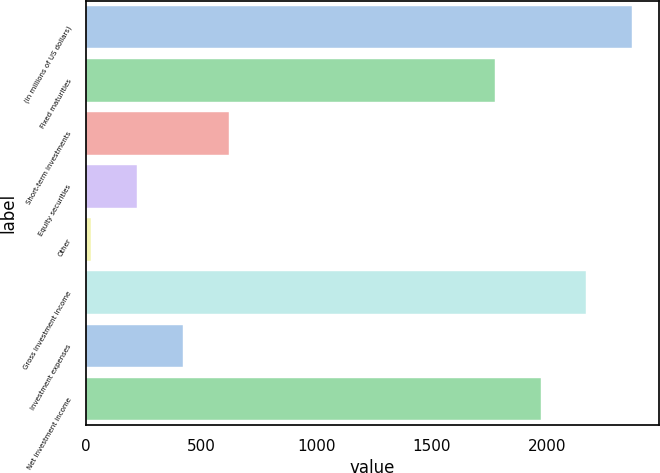<chart> <loc_0><loc_0><loc_500><loc_500><bar_chart><fcel>(in millions of US dollars)<fcel>Fixed maturities<fcel>Short-term investments<fcel>Equity securities<fcel>Other<fcel>Gross investment income<fcel>Investment expenses<fcel>Net investment income<nl><fcel>2367.6<fcel>1773<fcel>619.6<fcel>223.2<fcel>25<fcel>2169.4<fcel>421.4<fcel>1971.2<nl></chart> 